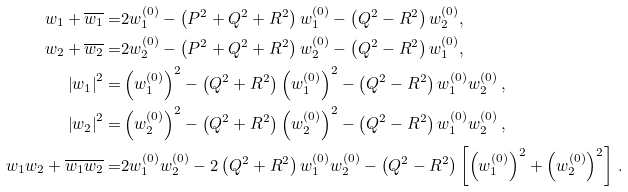Convert formula to latex. <formula><loc_0><loc_0><loc_500><loc_500>w _ { 1 } + \overline { w _ { 1 } } = & 2 w _ { 1 } ^ { ( 0 ) } - \left ( P ^ { 2 } + Q ^ { 2 } + R ^ { 2 } \right ) w _ { 1 } ^ { ( 0 ) } - \left ( Q ^ { 2 } - R ^ { 2 } \right ) w _ { 2 } ^ { ( 0 ) } , \\ w _ { 2 } + \overline { w _ { 2 } } = & 2 w _ { 2 } ^ { ( 0 ) } - \left ( P ^ { 2 } + Q ^ { 2 } + R ^ { 2 } \right ) w _ { 2 } ^ { ( 0 ) } - \left ( Q ^ { 2 } - R ^ { 2 } \right ) w _ { 1 } ^ { ( 0 ) } , \\ \left | w _ { 1 } \right | ^ { 2 } = & \left ( w _ { 1 } ^ { ( 0 ) } \right ) ^ { 2 } - \left ( Q ^ { 2 } + R ^ { 2 } \right ) \left ( w _ { 1 } ^ { ( 0 ) } \right ) ^ { 2 } - \left ( Q ^ { 2 } - R ^ { 2 } \right ) w _ { 1 } ^ { ( 0 ) } w _ { 2 } ^ { ( 0 ) } \, , \\ \left | w _ { 2 } \right | ^ { 2 } = & \left ( w _ { 2 } ^ { ( 0 ) } \right ) ^ { 2 } - \left ( Q ^ { 2 } + R ^ { 2 } \right ) \left ( w _ { 2 } ^ { ( 0 ) } \right ) ^ { 2 } - \left ( Q ^ { 2 } - R ^ { 2 } \right ) w _ { 1 } ^ { ( 0 ) } w _ { 2 } ^ { ( 0 ) } \, , \\ w _ { 1 } w _ { 2 } + \overline { w _ { 1 } } \overline { w _ { 2 } } = & 2 w _ { 1 } ^ { ( 0 ) } w _ { 2 } ^ { ( 0 ) } - 2 \left ( Q ^ { 2 } + R ^ { 2 } \right ) w _ { 1 } ^ { ( 0 ) } w _ { 2 } ^ { ( 0 ) } - \left ( Q ^ { 2 } - R ^ { 2 } \right ) \left [ \left ( w _ { 1 } ^ { ( 0 ) } \right ) ^ { 2 } + \left ( w _ { 2 } ^ { ( 0 ) } \right ) ^ { 2 } \right ] \, .</formula> 